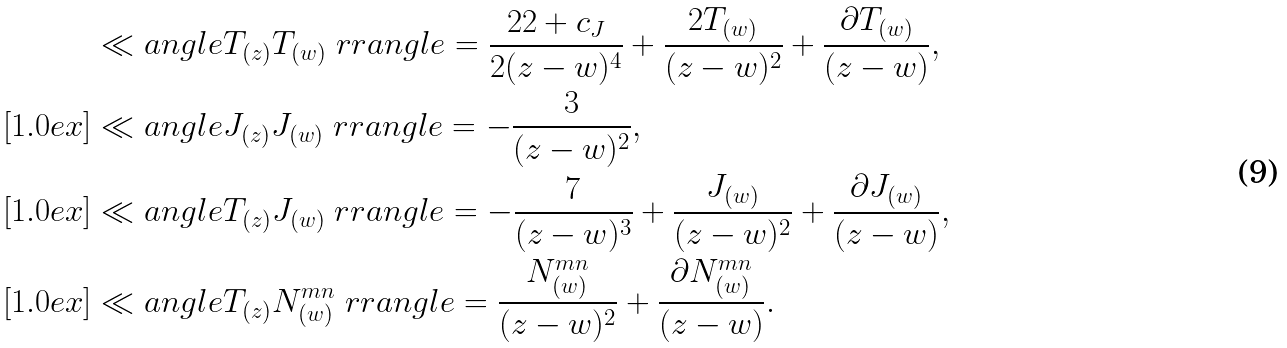Convert formula to latex. <formula><loc_0><loc_0><loc_500><loc_500>& \ll a n g l e T _ { ( z ) } T _ { ( w ) } \ r r a n g l e = \frac { 2 2 + c _ { J } } { { 2 ( z - w ) ^ { 4 } } } + \frac { 2 T _ { ( w ) } } { ( z - w ) ^ { 2 } } + \frac { \partial T _ { ( w ) } } { ( z - w ) } , \\ [ 1 . 0 e x ] & \ll a n g l e J _ { ( z ) } J _ { ( w ) } \ r r a n g l e = - \frac { 3 } { ( z - w ) ^ { 2 } } , \\ [ 1 . 0 e x ] & \ll a n g l e T _ { ( z ) } J _ { ( w ) } \ r r a n g l e = - \frac { 7 } { ( z - w ) ^ { 3 } } + \frac { J _ { ( w ) } } { ( z - w ) ^ { 2 } } + \frac { \partial J _ { ( w ) } } { ( z - w ) } , \\ [ 1 . 0 e x ] & \ll a n g l e T _ { ( z ) } N ^ { m n } _ { ( w ) } \ r r a n g l e = \frac { N ^ { m n } _ { ( w ) } } { ( z - w ) ^ { 2 } } + \frac { \partial N ^ { m n } _ { ( w ) } } { ( z - w ) } .</formula> 